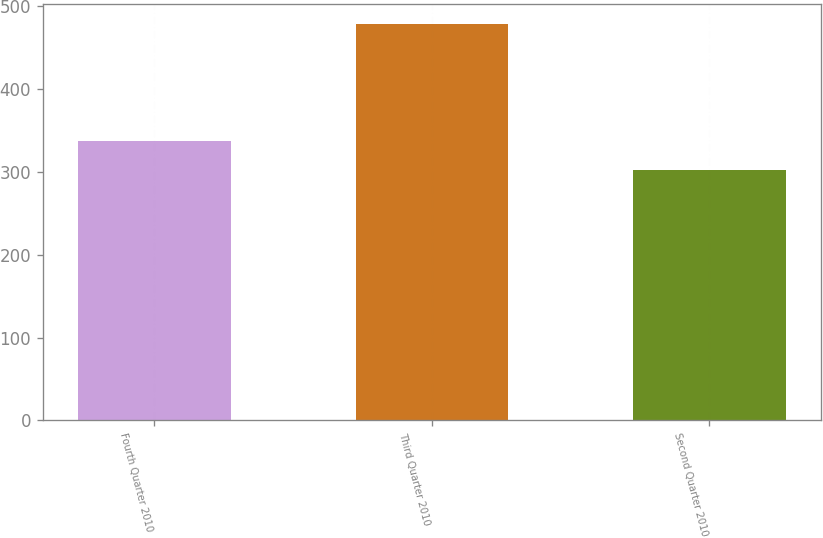Convert chart. <chart><loc_0><loc_0><loc_500><loc_500><bar_chart><fcel>Fourth Quarter 2010<fcel>Third Quarter 2010<fcel>Second Quarter 2010<nl><fcel>338<fcel>479<fcel>303<nl></chart> 